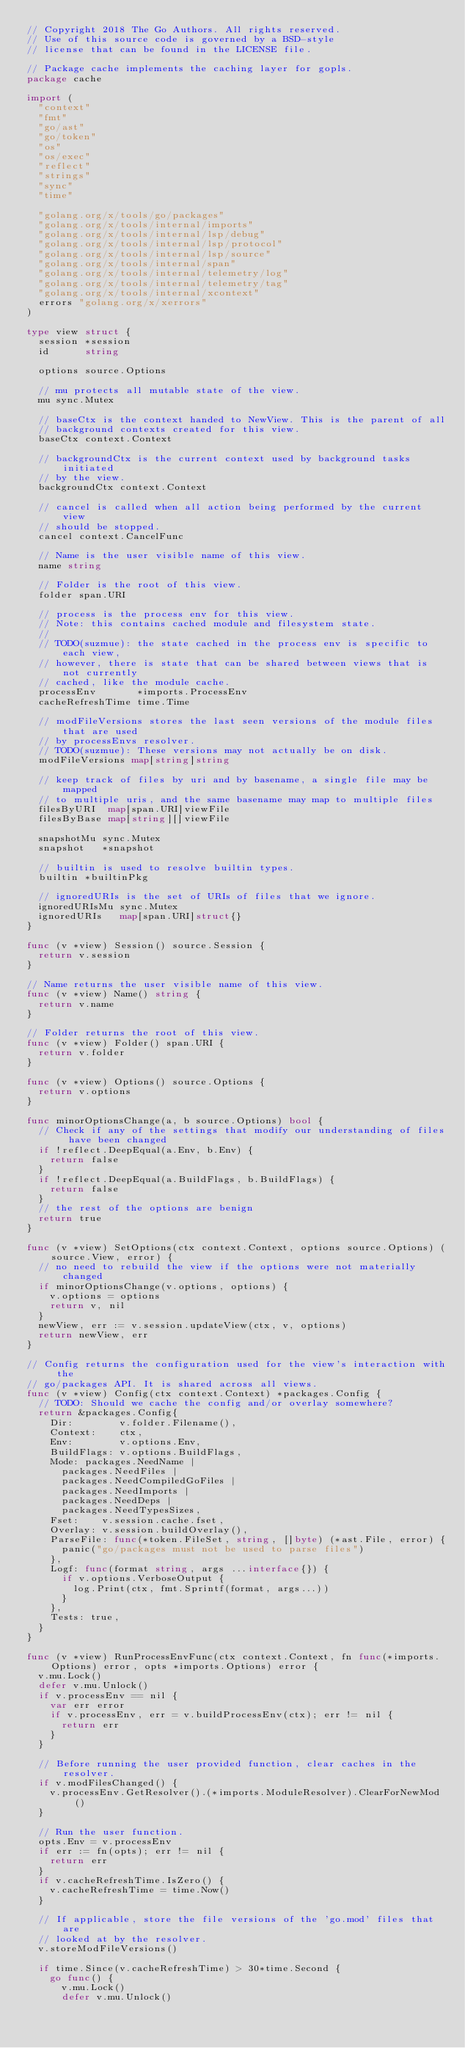<code> <loc_0><loc_0><loc_500><loc_500><_Go_>// Copyright 2018 The Go Authors. All rights reserved.
// Use of this source code is governed by a BSD-style
// license that can be found in the LICENSE file.

// Package cache implements the caching layer for gopls.
package cache

import (
	"context"
	"fmt"
	"go/ast"
	"go/token"
	"os"
	"os/exec"
	"reflect"
	"strings"
	"sync"
	"time"

	"golang.org/x/tools/go/packages"
	"golang.org/x/tools/internal/imports"
	"golang.org/x/tools/internal/lsp/debug"
	"golang.org/x/tools/internal/lsp/protocol"
	"golang.org/x/tools/internal/lsp/source"
	"golang.org/x/tools/internal/span"
	"golang.org/x/tools/internal/telemetry/log"
	"golang.org/x/tools/internal/telemetry/tag"
	"golang.org/x/tools/internal/xcontext"
	errors "golang.org/x/xerrors"
)

type view struct {
	session *session
	id      string

	options source.Options

	// mu protects all mutable state of the view.
	mu sync.Mutex

	// baseCtx is the context handed to NewView. This is the parent of all
	// background contexts created for this view.
	baseCtx context.Context

	// backgroundCtx is the current context used by background tasks initiated
	// by the view.
	backgroundCtx context.Context

	// cancel is called when all action being performed by the current view
	// should be stopped.
	cancel context.CancelFunc

	// Name is the user visible name of this view.
	name string

	// Folder is the root of this view.
	folder span.URI

	// process is the process env for this view.
	// Note: this contains cached module and filesystem state.
	//
	// TODO(suzmue): the state cached in the process env is specific to each view,
	// however, there is state that can be shared between views that is not currently
	// cached, like the module cache.
	processEnv       *imports.ProcessEnv
	cacheRefreshTime time.Time

	// modFileVersions stores the last seen versions of the module files that are used
	// by processEnvs resolver.
	// TODO(suzmue): These versions may not actually be on disk.
	modFileVersions map[string]string

	// keep track of files by uri and by basename, a single file may be mapped
	// to multiple uris, and the same basename may map to multiple files
	filesByURI  map[span.URI]viewFile
	filesByBase map[string][]viewFile

	snapshotMu sync.Mutex
	snapshot   *snapshot

	// builtin is used to resolve builtin types.
	builtin *builtinPkg

	// ignoredURIs is the set of URIs of files that we ignore.
	ignoredURIsMu sync.Mutex
	ignoredURIs   map[span.URI]struct{}
}

func (v *view) Session() source.Session {
	return v.session
}

// Name returns the user visible name of this view.
func (v *view) Name() string {
	return v.name
}

// Folder returns the root of this view.
func (v *view) Folder() span.URI {
	return v.folder
}

func (v *view) Options() source.Options {
	return v.options
}

func minorOptionsChange(a, b source.Options) bool {
	// Check if any of the settings that modify our understanding of files have been changed
	if !reflect.DeepEqual(a.Env, b.Env) {
		return false
	}
	if !reflect.DeepEqual(a.BuildFlags, b.BuildFlags) {
		return false
	}
	// the rest of the options are benign
	return true
}

func (v *view) SetOptions(ctx context.Context, options source.Options) (source.View, error) {
	// no need to rebuild the view if the options were not materially changed
	if minorOptionsChange(v.options, options) {
		v.options = options
		return v, nil
	}
	newView, err := v.session.updateView(ctx, v, options)
	return newView, err
}

// Config returns the configuration used for the view's interaction with the
// go/packages API. It is shared across all views.
func (v *view) Config(ctx context.Context) *packages.Config {
	// TODO: Should we cache the config and/or overlay somewhere?
	return &packages.Config{
		Dir:        v.folder.Filename(),
		Context:    ctx,
		Env:        v.options.Env,
		BuildFlags: v.options.BuildFlags,
		Mode: packages.NeedName |
			packages.NeedFiles |
			packages.NeedCompiledGoFiles |
			packages.NeedImports |
			packages.NeedDeps |
			packages.NeedTypesSizes,
		Fset:    v.session.cache.fset,
		Overlay: v.session.buildOverlay(),
		ParseFile: func(*token.FileSet, string, []byte) (*ast.File, error) {
			panic("go/packages must not be used to parse files")
		},
		Logf: func(format string, args ...interface{}) {
			if v.options.VerboseOutput {
				log.Print(ctx, fmt.Sprintf(format, args...))
			}
		},
		Tests: true,
	}
}

func (v *view) RunProcessEnvFunc(ctx context.Context, fn func(*imports.Options) error, opts *imports.Options) error {
	v.mu.Lock()
	defer v.mu.Unlock()
	if v.processEnv == nil {
		var err error
		if v.processEnv, err = v.buildProcessEnv(ctx); err != nil {
			return err
		}
	}

	// Before running the user provided function, clear caches in the resolver.
	if v.modFilesChanged() {
		v.processEnv.GetResolver().(*imports.ModuleResolver).ClearForNewMod()
	}

	// Run the user function.
	opts.Env = v.processEnv
	if err := fn(opts); err != nil {
		return err
	}
	if v.cacheRefreshTime.IsZero() {
		v.cacheRefreshTime = time.Now()
	}

	// If applicable, store the file versions of the 'go.mod' files that are
	// looked at by the resolver.
	v.storeModFileVersions()

	if time.Since(v.cacheRefreshTime) > 30*time.Second {
		go func() {
			v.mu.Lock()
			defer v.mu.Unlock()
</code> 